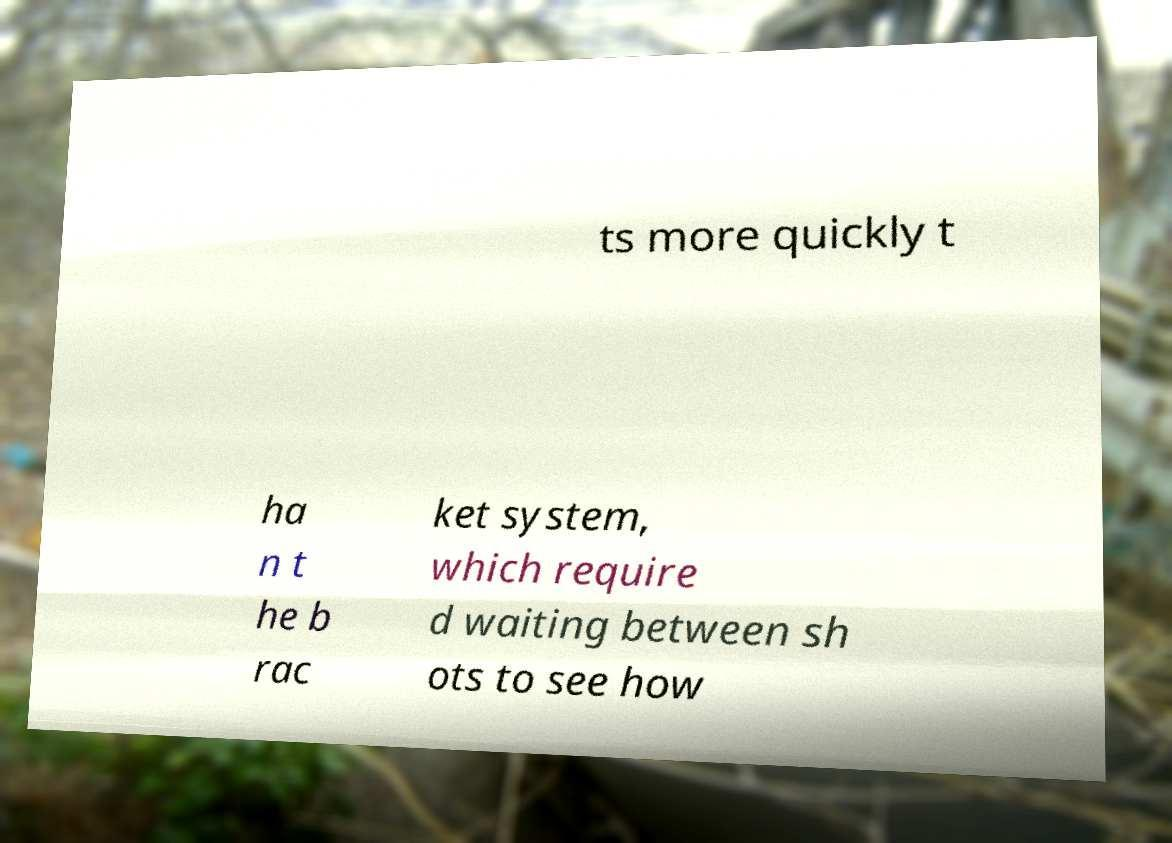There's text embedded in this image that I need extracted. Can you transcribe it verbatim? ts more quickly t ha n t he b rac ket system, which require d waiting between sh ots to see how 